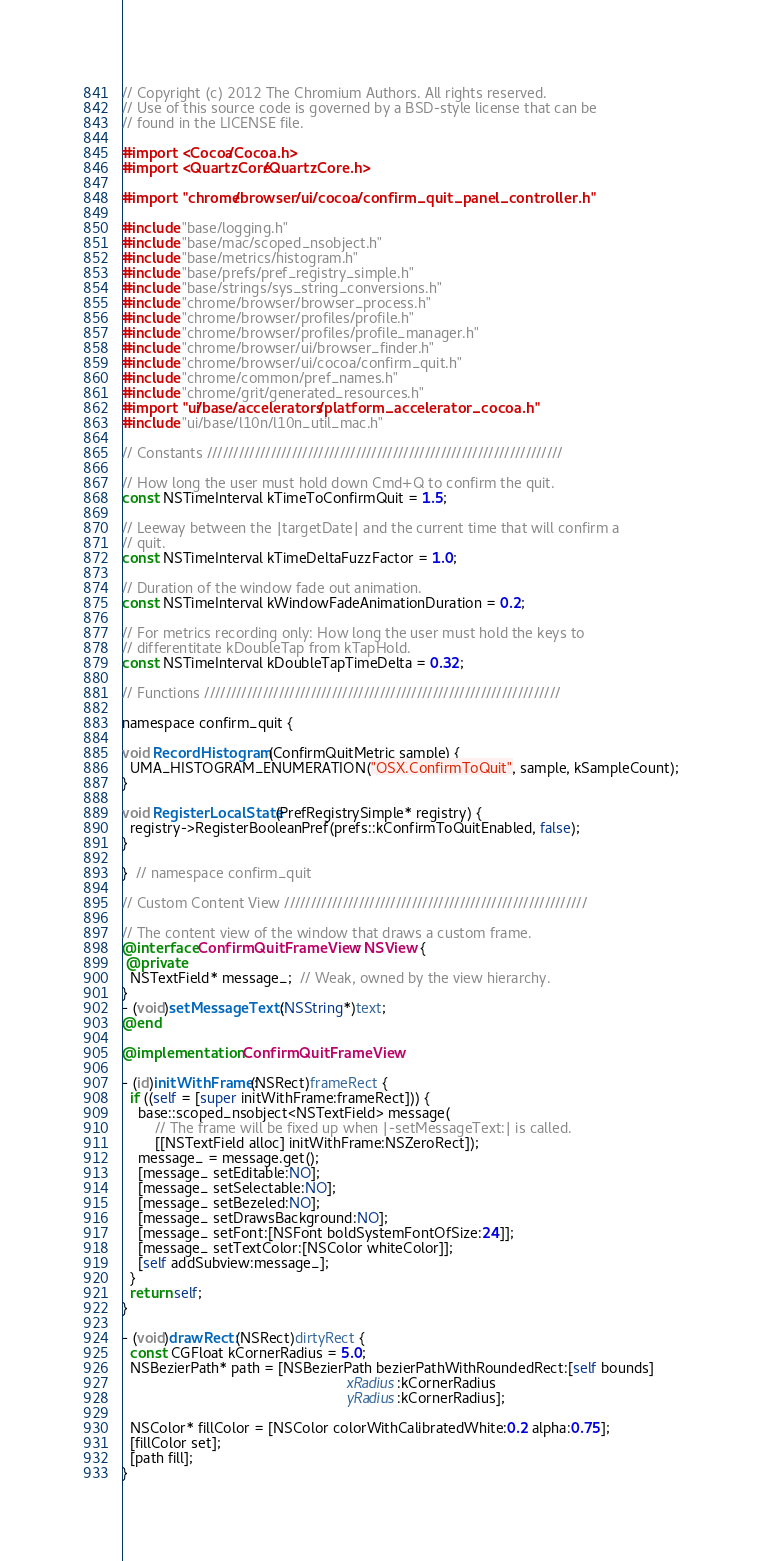<code> <loc_0><loc_0><loc_500><loc_500><_ObjectiveC_>// Copyright (c) 2012 The Chromium Authors. All rights reserved.
// Use of this source code is governed by a BSD-style license that can be
// found in the LICENSE file.

#import <Cocoa/Cocoa.h>
#import <QuartzCore/QuartzCore.h>

#import "chrome/browser/ui/cocoa/confirm_quit_panel_controller.h"

#include "base/logging.h"
#include "base/mac/scoped_nsobject.h"
#include "base/metrics/histogram.h"
#include "base/prefs/pref_registry_simple.h"
#include "base/strings/sys_string_conversions.h"
#include "chrome/browser/browser_process.h"
#include "chrome/browser/profiles/profile.h"
#include "chrome/browser/profiles/profile_manager.h"
#include "chrome/browser/ui/browser_finder.h"
#include "chrome/browser/ui/cocoa/confirm_quit.h"
#include "chrome/common/pref_names.h"
#include "chrome/grit/generated_resources.h"
#import "ui/base/accelerators/platform_accelerator_cocoa.h"
#include "ui/base/l10n/l10n_util_mac.h"

// Constants ///////////////////////////////////////////////////////////////////

// How long the user must hold down Cmd+Q to confirm the quit.
const NSTimeInterval kTimeToConfirmQuit = 1.5;

// Leeway between the |targetDate| and the current time that will confirm a
// quit.
const NSTimeInterval kTimeDeltaFuzzFactor = 1.0;

// Duration of the window fade out animation.
const NSTimeInterval kWindowFadeAnimationDuration = 0.2;

// For metrics recording only: How long the user must hold the keys to
// differentitate kDoubleTap from kTapHold.
const NSTimeInterval kDoubleTapTimeDelta = 0.32;

// Functions ///////////////////////////////////////////////////////////////////

namespace confirm_quit {

void RecordHistogram(ConfirmQuitMetric sample) {
  UMA_HISTOGRAM_ENUMERATION("OSX.ConfirmToQuit", sample, kSampleCount);
}

void RegisterLocalState(PrefRegistrySimple* registry) {
  registry->RegisterBooleanPref(prefs::kConfirmToQuitEnabled, false);
}

}  // namespace confirm_quit

// Custom Content View /////////////////////////////////////////////////////////

// The content view of the window that draws a custom frame.
@interface ConfirmQuitFrameView : NSView {
 @private
  NSTextField* message_;  // Weak, owned by the view hierarchy.
}
- (void)setMessageText:(NSString*)text;
@end

@implementation ConfirmQuitFrameView

- (id)initWithFrame:(NSRect)frameRect {
  if ((self = [super initWithFrame:frameRect])) {
    base::scoped_nsobject<NSTextField> message(
        // The frame will be fixed up when |-setMessageText:| is called.
        [[NSTextField alloc] initWithFrame:NSZeroRect]);
    message_ = message.get();
    [message_ setEditable:NO];
    [message_ setSelectable:NO];
    [message_ setBezeled:NO];
    [message_ setDrawsBackground:NO];
    [message_ setFont:[NSFont boldSystemFontOfSize:24]];
    [message_ setTextColor:[NSColor whiteColor]];
    [self addSubview:message_];
  }
  return self;
}

- (void)drawRect:(NSRect)dirtyRect {
  const CGFloat kCornerRadius = 5.0;
  NSBezierPath* path = [NSBezierPath bezierPathWithRoundedRect:[self bounds]
                                                       xRadius:kCornerRadius
                                                       yRadius:kCornerRadius];

  NSColor* fillColor = [NSColor colorWithCalibratedWhite:0.2 alpha:0.75];
  [fillColor set];
  [path fill];
}
</code> 